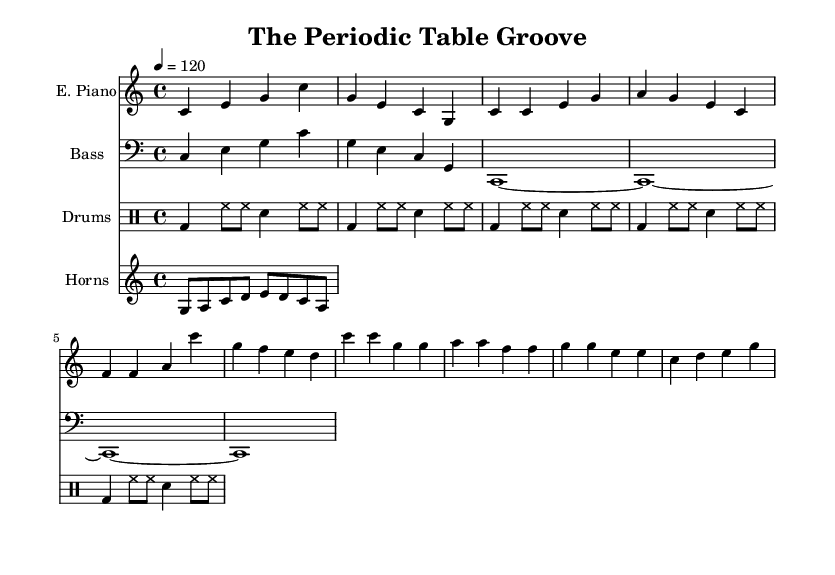What is the key signature of this music? The key signature is C major, indicated by the absence of sharps or flats in the music. This can be confirmed by looking at the clef and the notes presented in the piece.
Answer: C major What is the time signature of this music? The time signature is 4/4, which is typically seen at the beginning of the piece. This indicates that there are four beats in a measure and the quarter note receives one beat.
Answer: 4/4 What is the tempo marking for this piece? The tempo marking is given as "4 = 120," which refers to a quarter note getting 120 beats per minute. This provides a clear indication of the speed of the piece.
Answer: 120 What is the structure of the main electric piano riff? The electric piano riff is structured around a repeating pattern of notes primarily featuring chord progressions, which can be analyzed by tracing through the bars and identifying their relationships.
Answer: Repeating chord progressions How many measures are presented for the drum part? The drum part consists of five measures, as indicated by the notation, which can be counted by visually assessing the sections delineated by bar lines in the drummode.
Answer: Five What instruments are included in this arrangement? The arrangement includes electric piano, bass guitar, drums, and horns, as identified by looking at the instrument names provided at the beginning of each staff.
Answer: Electric piano, bass, drums, horns What musical style is this piece an example of? The piece exemplifies the soul genre, which can be confirmed by its rhythmic style, rhythmic bass lines, and overall groove characteristic of soul music.
Answer: Soul 